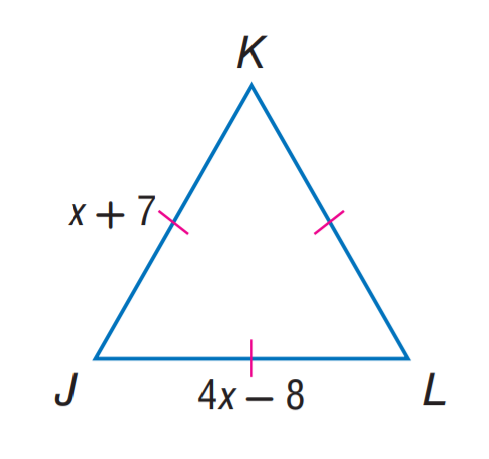Answer the mathemtical geometry problem and directly provide the correct option letter.
Question: Find x.
Choices: A: 5 B: 7 C: 8 D: 12 A 